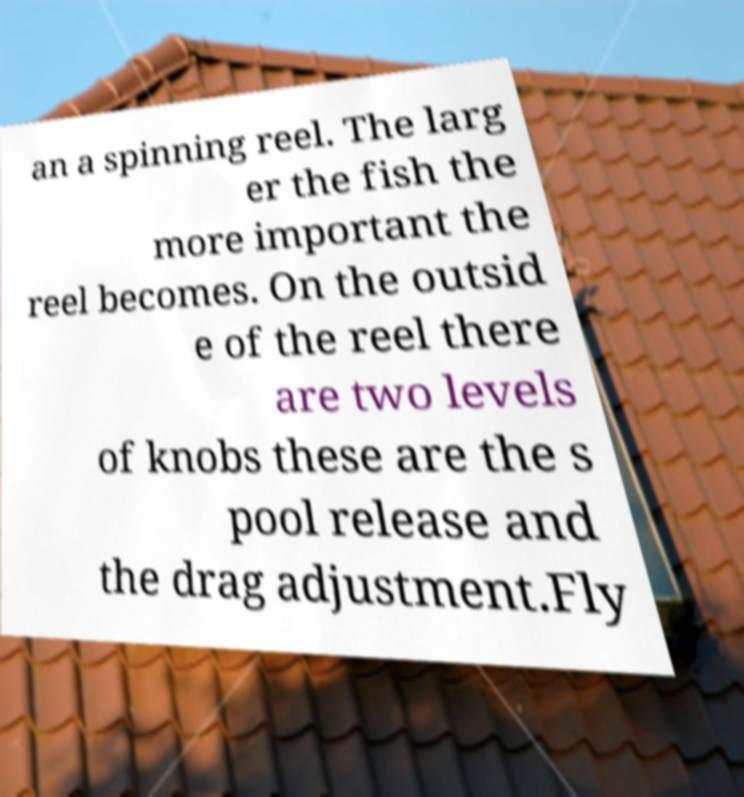Please read and relay the text visible in this image. What does it say? an a spinning reel. The larg er the fish the more important the reel becomes. On the outsid e of the reel there are two levels of knobs these are the s pool release and the drag adjustment.Fly 